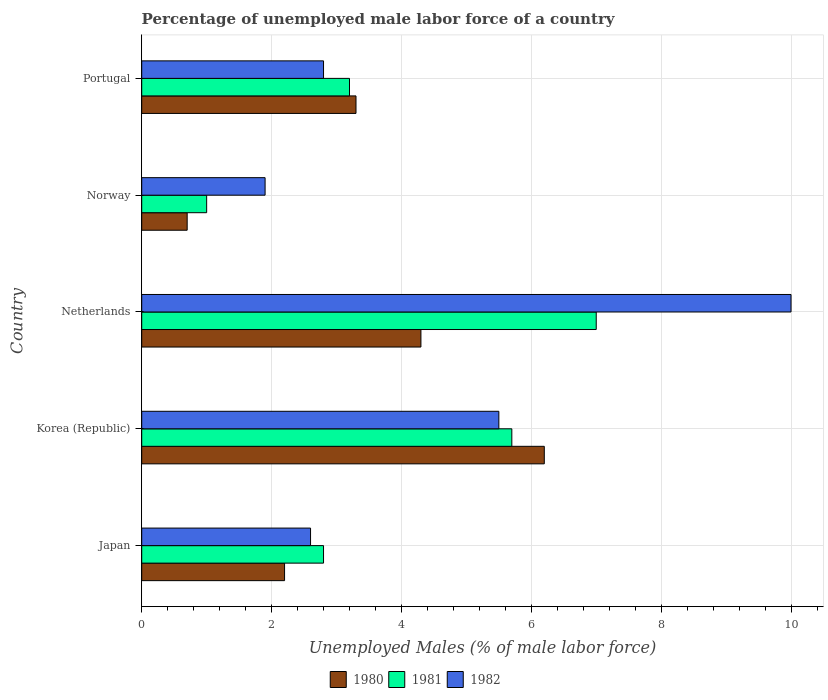How many different coloured bars are there?
Provide a succinct answer. 3. How many groups of bars are there?
Give a very brief answer. 5. How many bars are there on the 3rd tick from the top?
Give a very brief answer. 3. How many bars are there on the 3rd tick from the bottom?
Your response must be concise. 3. Across all countries, what is the maximum percentage of unemployed male labor force in 1980?
Your response must be concise. 6.2. Across all countries, what is the minimum percentage of unemployed male labor force in 1980?
Your answer should be compact. 0.7. In which country was the percentage of unemployed male labor force in 1980 maximum?
Your answer should be very brief. Korea (Republic). What is the total percentage of unemployed male labor force in 1980 in the graph?
Your response must be concise. 16.7. What is the difference between the percentage of unemployed male labor force in 1980 in Japan and that in Korea (Republic)?
Make the answer very short. -4. What is the difference between the percentage of unemployed male labor force in 1981 in Japan and the percentage of unemployed male labor force in 1982 in Portugal?
Your response must be concise. 0. What is the average percentage of unemployed male labor force in 1981 per country?
Your answer should be compact. 3.94. What is the difference between the percentage of unemployed male labor force in 1981 and percentage of unemployed male labor force in 1982 in Korea (Republic)?
Offer a very short reply. 0.2. What is the ratio of the percentage of unemployed male labor force in 1982 in Korea (Republic) to that in Portugal?
Keep it short and to the point. 1.96. Is the difference between the percentage of unemployed male labor force in 1981 in Japan and Portugal greater than the difference between the percentage of unemployed male labor force in 1982 in Japan and Portugal?
Keep it short and to the point. No. What is the difference between the highest and the lowest percentage of unemployed male labor force in 1982?
Your response must be concise. 8.1. In how many countries, is the percentage of unemployed male labor force in 1982 greater than the average percentage of unemployed male labor force in 1982 taken over all countries?
Provide a succinct answer. 2. Is the sum of the percentage of unemployed male labor force in 1981 in Norway and Portugal greater than the maximum percentage of unemployed male labor force in 1982 across all countries?
Your answer should be compact. No. What does the 2nd bar from the top in Portugal represents?
Offer a terse response. 1981. What does the 3rd bar from the bottom in Korea (Republic) represents?
Ensure brevity in your answer.  1982. How many bars are there?
Keep it short and to the point. 15. How many countries are there in the graph?
Provide a short and direct response. 5. Where does the legend appear in the graph?
Your answer should be very brief. Bottom center. How many legend labels are there?
Ensure brevity in your answer.  3. What is the title of the graph?
Your response must be concise. Percentage of unemployed male labor force of a country. What is the label or title of the X-axis?
Offer a very short reply. Unemployed Males (% of male labor force). What is the label or title of the Y-axis?
Offer a very short reply. Country. What is the Unemployed Males (% of male labor force) of 1980 in Japan?
Provide a succinct answer. 2.2. What is the Unemployed Males (% of male labor force) of 1981 in Japan?
Your response must be concise. 2.8. What is the Unemployed Males (% of male labor force) of 1982 in Japan?
Offer a very short reply. 2.6. What is the Unemployed Males (% of male labor force) of 1980 in Korea (Republic)?
Offer a terse response. 6.2. What is the Unemployed Males (% of male labor force) in 1981 in Korea (Republic)?
Your answer should be compact. 5.7. What is the Unemployed Males (% of male labor force) in 1980 in Netherlands?
Your answer should be very brief. 4.3. What is the Unemployed Males (% of male labor force) of 1982 in Netherlands?
Keep it short and to the point. 10. What is the Unemployed Males (% of male labor force) in 1980 in Norway?
Provide a succinct answer. 0.7. What is the Unemployed Males (% of male labor force) in 1981 in Norway?
Ensure brevity in your answer.  1. What is the Unemployed Males (% of male labor force) in 1982 in Norway?
Provide a succinct answer. 1.9. What is the Unemployed Males (% of male labor force) in 1980 in Portugal?
Keep it short and to the point. 3.3. What is the Unemployed Males (% of male labor force) of 1981 in Portugal?
Your answer should be very brief. 3.2. What is the Unemployed Males (% of male labor force) of 1982 in Portugal?
Give a very brief answer. 2.8. Across all countries, what is the maximum Unemployed Males (% of male labor force) in 1980?
Your answer should be very brief. 6.2. Across all countries, what is the maximum Unemployed Males (% of male labor force) in 1982?
Your answer should be compact. 10. Across all countries, what is the minimum Unemployed Males (% of male labor force) of 1980?
Your response must be concise. 0.7. Across all countries, what is the minimum Unemployed Males (% of male labor force) of 1981?
Keep it short and to the point. 1. Across all countries, what is the minimum Unemployed Males (% of male labor force) in 1982?
Ensure brevity in your answer.  1.9. What is the total Unemployed Males (% of male labor force) in 1980 in the graph?
Offer a very short reply. 16.7. What is the total Unemployed Males (% of male labor force) in 1981 in the graph?
Your answer should be very brief. 19.7. What is the total Unemployed Males (% of male labor force) of 1982 in the graph?
Ensure brevity in your answer.  22.8. What is the difference between the Unemployed Males (% of male labor force) in 1980 in Japan and that in Korea (Republic)?
Your answer should be very brief. -4. What is the difference between the Unemployed Males (% of male labor force) of 1982 in Japan and that in Netherlands?
Give a very brief answer. -7.4. What is the difference between the Unemployed Males (% of male labor force) in 1981 in Japan and that in Norway?
Your response must be concise. 1.8. What is the difference between the Unemployed Males (% of male labor force) in 1982 in Japan and that in Norway?
Give a very brief answer. 0.7. What is the difference between the Unemployed Males (% of male labor force) in 1981 in Korea (Republic) and that in Netherlands?
Your answer should be compact. -1.3. What is the difference between the Unemployed Males (% of male labor force) of 1980 in Korea (Republic) and that in Norway?
Your answer should be compact. 5.5. What is the difference between the Unemployed Males (% of male labor force) in 1980 in Korea (Republic) and that in Portugal?
Your response must be concise. 2.9. What is the difference between the Unemployed Males (% of male labor force) of 1981 in Netherlands and that in Norway?
Your answer should be compact. 6. What is the difference between the Unemployed Males (% of male labor force) of 1981 in Netherlands and that in Portugal?
Make the answer very short. 3.8. What is the difference between the Unemployed Males (% of male labor force) in 1982 in Netherlands and that in Portugal?
Make the answer very short. 7.2. What is the difference between the Unemployed Males (% of male labor force) of 1980 in Norway and that in Portugal?
Provide a short and direct response. -2.6. What is the difference between the Unemployed Males (% of male labor force) in 1981 in Norway and that in Portugal?
Provide a succinct answer. -2.2. What is the difference between the Unemployed Males (% of male labor force) in 1982 in Norway and that in Portugal?
Offer a very short reply. -0.9. What is the difference between the Unemployed Males (% of male labor force) in 1980 in Japan and the Unemployed Males (% of male labor force) in 1982 in Korea (Republic)?
Ensure brevity in your answer.  -3.3. What is the difference between the Unemployed Males (% of male labor force) of 1981 in Japan and the Unemployed Males (% of male labor force) of 1982 in Korea (Republic)?
Keep it short and to the point. -2.7. What is the difference between the Unemployed Males (% of male labor force) of 1980 in Japan and the Unemployed Males (% of male labor force) of 1981 in Netherlands?
Your answer should be compact. -4.8. What is the difference between the Unemployed Males (% of male labor force) of 1981 in Japan and the Unemployed Males (% of male labor force) of 1982 in Netherlands?
Provide a short and direct response. -7.2. What is the difference between the Unemployed Males (% of male labor force) in 1980 in Japan and the Unemployed Males (% of male labor force) in 1982 in Norway?
Offer a terse response. 0.3. What is the difference between the Unemployed Males (% of male labor force) of 1981 in Japan and the Unemployed Males (% of male labor force) of 1982 in Norway?
Your answer should be very brief. 0.9. What is the difference between the Unemployed Males (% of male labor force) of 1980 in Japan and the Unemployed Males (% of male labor force) of 1981 in Portugal?
Offer a very short reply. -1. What is the difference between the Unemployed Males (% of male labor force) of 1980 in Japan and the Unemployed Males (% of male labor force) of 1982 in Portugal?
Your answer should be very brief. -0.6. What is the difference between the Unemployed Males (% of male labor force) of 1981 in Japan and the Unemployed Males (% of male labor force) of 1982 in Portugal?
Your response must be concise. 0. What is the difference between the Unemployed Males (% of male labor force) of 1980 in Korea (Republic) and the Unemployed Males (% of male labor force) of 1981 in Netherlands?
Your response must be concise. -0.8. What is the difference between the Unemployed Males (% of male labor force) in 1980 in Korea (Republic) and the Unemployed Males (% of male labor force) in 1982 in Norway?
Provide a succinct answer. 4.3. What is the difference between the Unemployed Males (% of male labor force) in 1981 in Korea (Republic) and the Unemployed Males (% of male labor force) in 1982 in Norway?
Your answer should be compact. 3.8. What is the difference between the Unemployed Males (% of male labor force) of 1980 in Korea (Republic) and the Unemployed Males (% of male labor force) of 1981 in Portugal?
Your response must be concise. 3. What is the difference between the Unemployed Males (% of male labor force) in 1980 in Netherlands and the Unemployed Males (% of male labor force) in 1981 in Norway?
Your answer should be very brief. 3.3. What is the difference between the Unemployed Males (% of male labor force) in 1980 in Netherlands and the Unemployed Males (% of male labor force) in 1982 in Norway?
Provide a short and direct response. 2.4. What is the difference between the Unemployed Males (% of male labor force) of 1980 in Netherlands and the Unemployed Males (% of male labor force) of 1981 in Portugal?
Offer a terse response. 1.1. What is the difference between the Unemployed Males (% of male labor force) in 1981 in Netherlands and the Unemployed Males (% of male labor force) in 1982 in Portugal?
Make the answer very short. 4.2. What is the difference between the Unemployed Males (% of male labor force) of 1980 in Norway and the Unemployed Males (% of male labor force) of 1981 in Portugal?
Provide a short and direct response. -2.5. What is the difference between the Unemployed Males (% of male labor force) of 1980 in Norway and the Unemployed Males (% of male labor force) of 1982 in Portugal?
Your answer should be compact. -2.1. What is the difference between the Unemployed Males (% of male labor force) in 1981 in Norway and the Unemployed Males (% of male labor force) in 1982 in Portugal?
Provide a short and direct response. -1.8. What is the average Unemployed Males (% of male labor force) of 1980 per country?
Keep it short and to the point. 3.34. What is the average Unemployed Males (% of male labor force) in 1981 per country?
Keep it short and to the point. 3.94. What is the average Unemployed Males (% of male labor force) in 1982 per country?
Your answer should be compact. 4.56. What is the difference between the Unemployed Males (% of male labor force) of 1980 and Unemployed Males (% of male labor force) of 1982 in Japan?
Make the answer very short. -0.4. What is the difference between the Unemployed Males (% of male labor force) in 1980 and Unemployed Males (% of male labor force) in 1981 in Korea (Republic)?
Provide a short and direct response. 0.5. What is the difference between the Unemployed Males (% of male labor force) of 1981 and Unemployed Males (% of male labor force) of 1982 in Korea (Republic)?
Keep it short and to the point. 0.2. What is the difference between the Unemployed Males (% of male labor force) of 1980 and Unemployed Males (% of male labor force) of 1982 in Norway?
Keep it short and to the point. -1.2. What is the difference between the Unemployed Males (% of male labor force) in 1981 and Unemployed Males (% of male labor force) in 1982 in Norway?
Your answer should be very brief. -0.9. What is the difference between the Unemployed Males (% of male labor force) of 1980 and Unemployed Males (% of male labor force) of 1981 in Portugal?
Provide a succinct answer. 0.1. What is the difference between the Unemployed Males (% of male labor force) in 1981 and Unemployed Males (% of male labor force) in 1982 in Portugal?
Ensure brevity in your answer.  0.4. What is the ratio of the Unemployed Males (% of male labor force) of 1980 in Japan to that in Korea (Republic)?
Your response must be concise. 0.35. What is the ratio of the Unemployed Males (% of male labor force) in 1981 in Japan to that in Korea (Republic)?
Offer a terse response. 0.49. What is the ratio of the Unemployed Males (% of male labor force) of 1982 in Japan to that in Korea (Republic)?
Provide a short and direct response. 0.47. What is the ratio of the Unemployed Males (% of male labor force) of 1980 in Japan to that in Netherlands?
Provide a succinct answer. 0.51. What is the ratio of the Unemployed Males (% of male labor force) in 1982 in Japan to that in Netherlands?
Provide a succinct answer. 0.26. What is the ratio of the Unemployed Males (% of male labor force) of 1980 in Japan to that in Norway?
Make the answer very short. 3.14. What is the ratio of the Unemployed Males (% of male labor force) of 1981 in Japan to that in Norway?
Provide a short and direct response. 2.8. What is the ratio of the Unemployed Males (% of male labor force) in 1982 in Japan to that in Norway?
Ensure brevity in your answer.  1.37. What is the ratio of the Unemployed Males (% of male labor force) in 1982 in Japan to that in Portugal?
Provide a short and direct response. 0.93. What is the ratio of the Unemployed Males (% of male labor force) in 1980 in Korea (Republic) to that in Netherlands?
Make the answer very short. 1.44. What is the ratio of the Unemployed Males (% of male labor force) in 1981 in Korea (Republic) to that in Netherlands?
Ensure brevity in your answer.  0.81. What is the ratio of the Unemployed Males (% of male labor force) of 1982 in Korea (Republic) to that in Netherlands?
Ensure brevity in your answer.  0.55. What is the ratio of the Unemployed Males (% of male labor force) of 1980 in Korea (Republic) to that in Norway?
Provide a succinct answer. 8.86. What is the ratio of the Unemployed Males (% of male labor force) of 1982 in Korea (Republic) to that in Norway?
Your answer should be very brief. 2.89. What is the ratio of the Unemployed Males (% of male labor force) in 1980 in Korea (Republic) to that in Portugal?
Give a very brief answer. 1.88. What is the ratio of the Unemployed Males (% of male labor force) of 1981 in Korea (Republic) to that in Portugal?
Ensure brevity in your answer.  1.78. What is the ratio of the Unemployed Males (% of male labor force) of 1982 in Korea (Republic) to that in Portugal?
Your response must be concise. 1.96. What is the ratio of the Unemployed Males (% of male labor force) of 1980 in Netherlands to that in Norway?
Make the answer very short. 6.14. What is the ratio of the Unemployed Males (% of male labor force) in 1981 in Netherlands to that in Norway?
Ensure brevity in your answer.  7. What is the ratio of the Unemployed Males (% of male labor force) of 1982 in Netherlands to that in Norway?
Offer a very short reply. 5.26. What is the ratio of the Unemployed Males (% of male labor force) of 1980 in Netherlands to that in Portugal?
Make the answer very short. 1.3. What is the ratio of the Unemployed Males (% of male labor force) in 1981 in Netherlands to that in Portugal?
Provide a succinct answer. 2.19. What is the ratio of the Unemployed Males (% of male labor force) of 1982 in Netherlands to that in Portugal?
Offer a very short reply. 3.57. What is the ratio of the Unemployed Males (% of male labor force) in 1980 in Norway to that in Portugal?
Offer a terse response. 0.21. What is the ratio of the Unemployed Males (% of male labor force) in 1981 in Norway to that in Portugal?
Provide a succinct answer. 0.31. What is the ratio of the Unemployed Males (% of male labor force) of 1982 in Norway to that in Portugal?
Your answer should be very brief. 0.68. What is the difference between the highest and the second highest Unemployed Males (% of male labor force) of 1980?
Your answer should be compact. 1.9. What is the difference between the highest and the lowest Unemployed Males (% of male labor force) in 1980?
Provide a short and direct response. 5.5. What is the difference between the highest and the lowest Unemployed Males (% of male labor force) of 1982?
Your answer should be very brief. 8.1. 